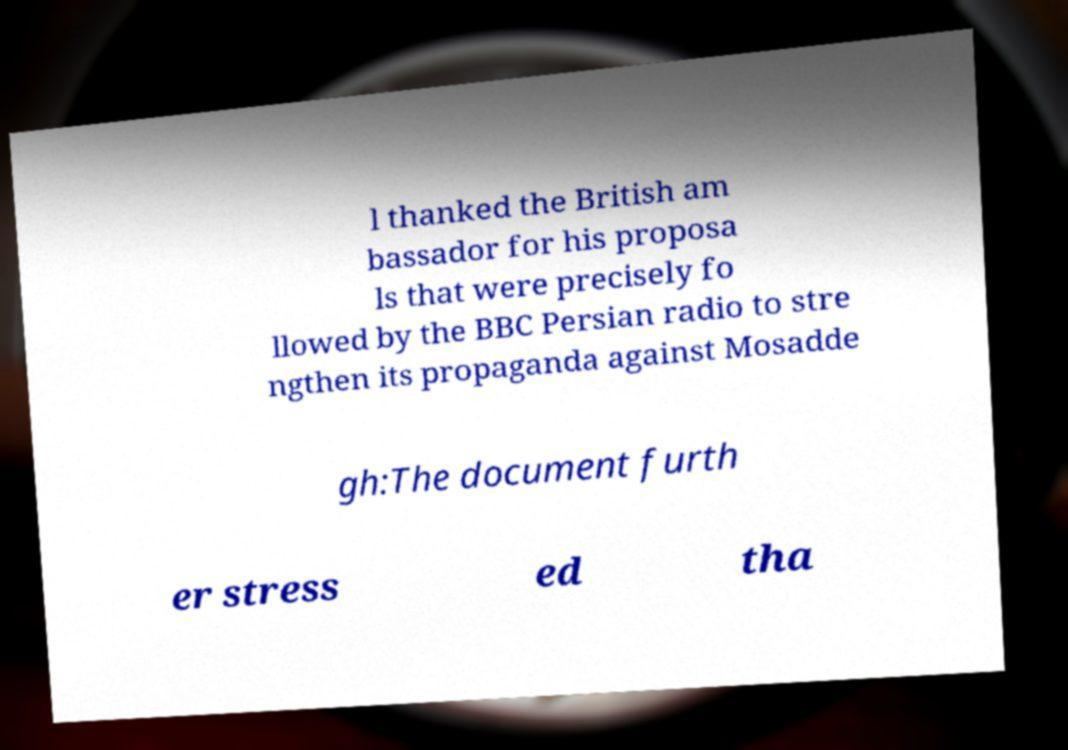Can you read and provide the text displayed in the image?This photo seems to have some interesting text. Can you extract and type it out for me? l thanked the British am bassador for his proposa ls that were precisely fo llowed by the BBC Persian radio to stre ngthen its propaganda against Mosadde gh:The document furth er stress ed tha 